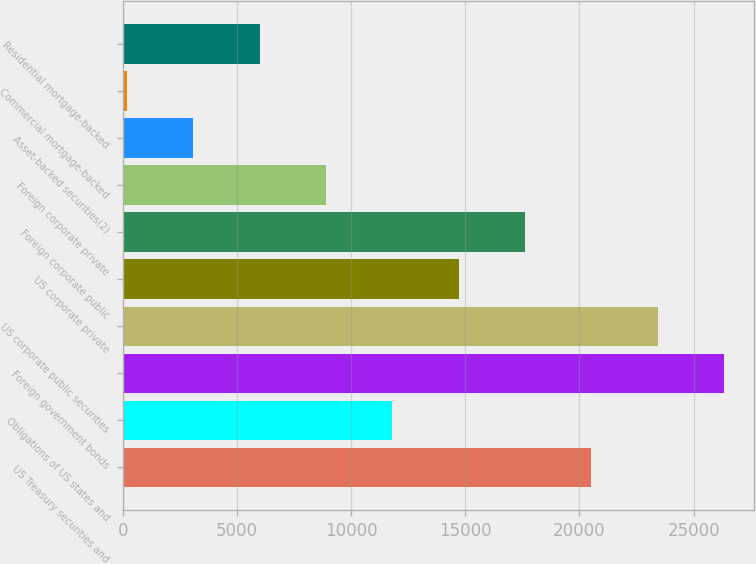Convert chart. <chart><loc_0><loc_0><loc_500><loc_500><bar_chart><fcel>US Treasury securities and<fcel>Obligations of US states and<fcel>Foreign government bonds<fcel>US corporate public securities<fcel>US corporate private<fcel>Foreign corporate public<fcel>Foreign corporate private<fcel>Asset-backed securities(2)<fcel>Commercial mortgage-backed<fcel>Residential mortgage-backed<nl><fcel>20526.5<fcel>11813<fcel>26335.5<fcel>23431<fcel>14717.5<fcel>17622<fcel>8908.5<fcel>3099.5<fcel>195<fcel>6004<nl></chart> 